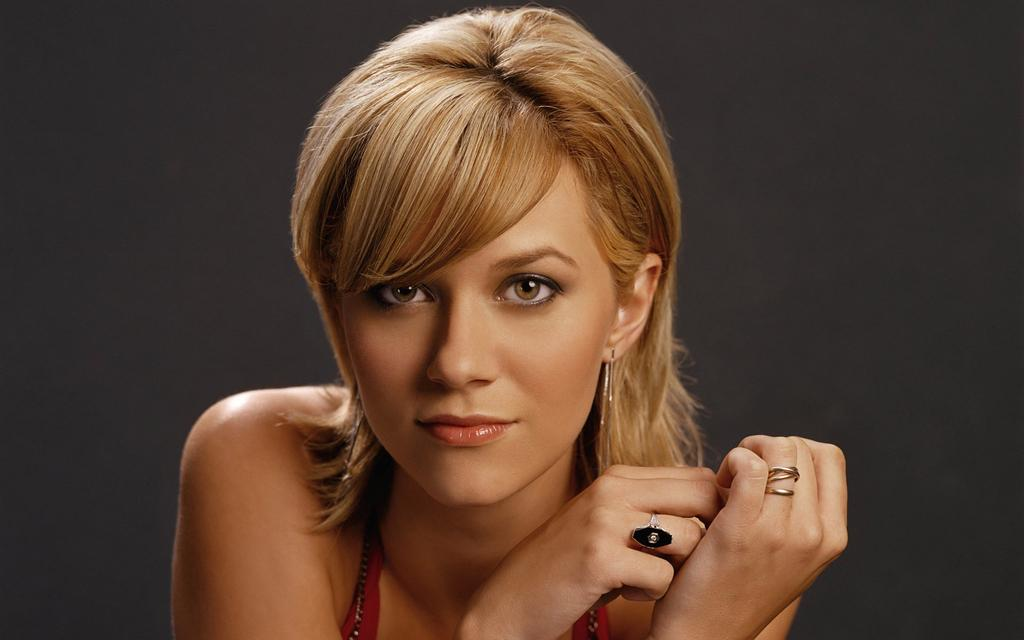Who is present in the image? There is a woman in the image. What can be seen behind the woman? The background of the image is black. What type of skirt is the monkey wearing in the image? There is no monkey present in the image, and therefore no skirt or clothing can be observed. 